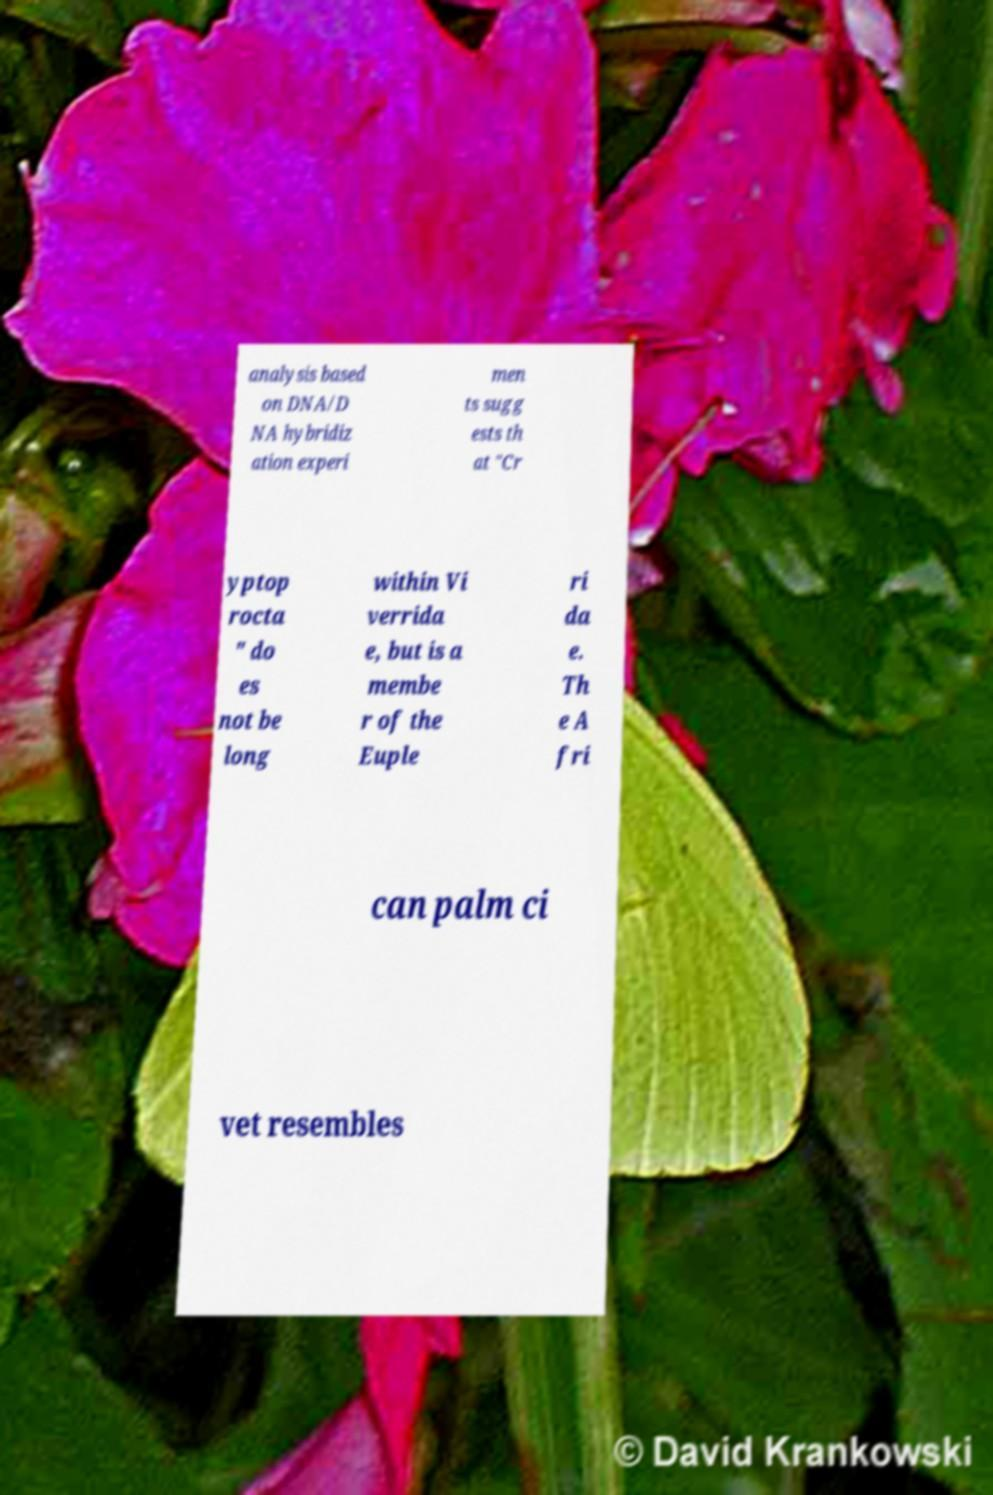Please read and relay the text visible in this image. What does it say? analysis based on DNA/D NA hybridiz ation experi men ts sugg ests th at "Cr yptop rocta " do es not be long within Vi verrida e, but is a membe r of the Euple ri da e. Th e A fri can palm ci vet resembles 